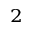<formula> <loc_0><loc_0><loc_500><loc_500>_ { 2 }</formula> 